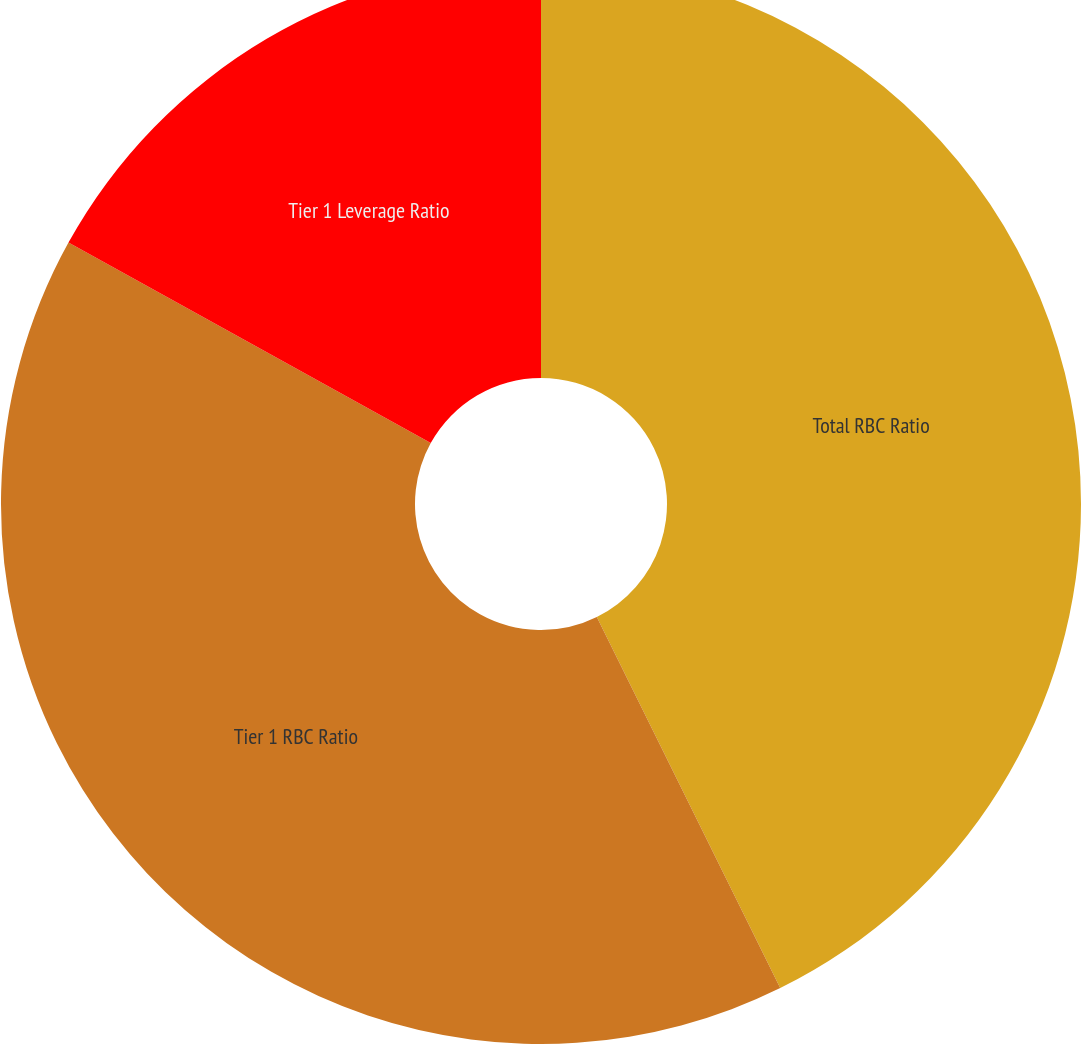Convert chart to OTSL. <chart><loc_0><loc_0><loc_500><loc_500><pie_chart><fcel>Total RBC Ratio<fcel>Tier 1 RBC Ratio<fcel>Tier 1 Leverage Ratio<nl><fcel>42.7%<fcel>40.35%<fcel>16.96%<nl></chart> 